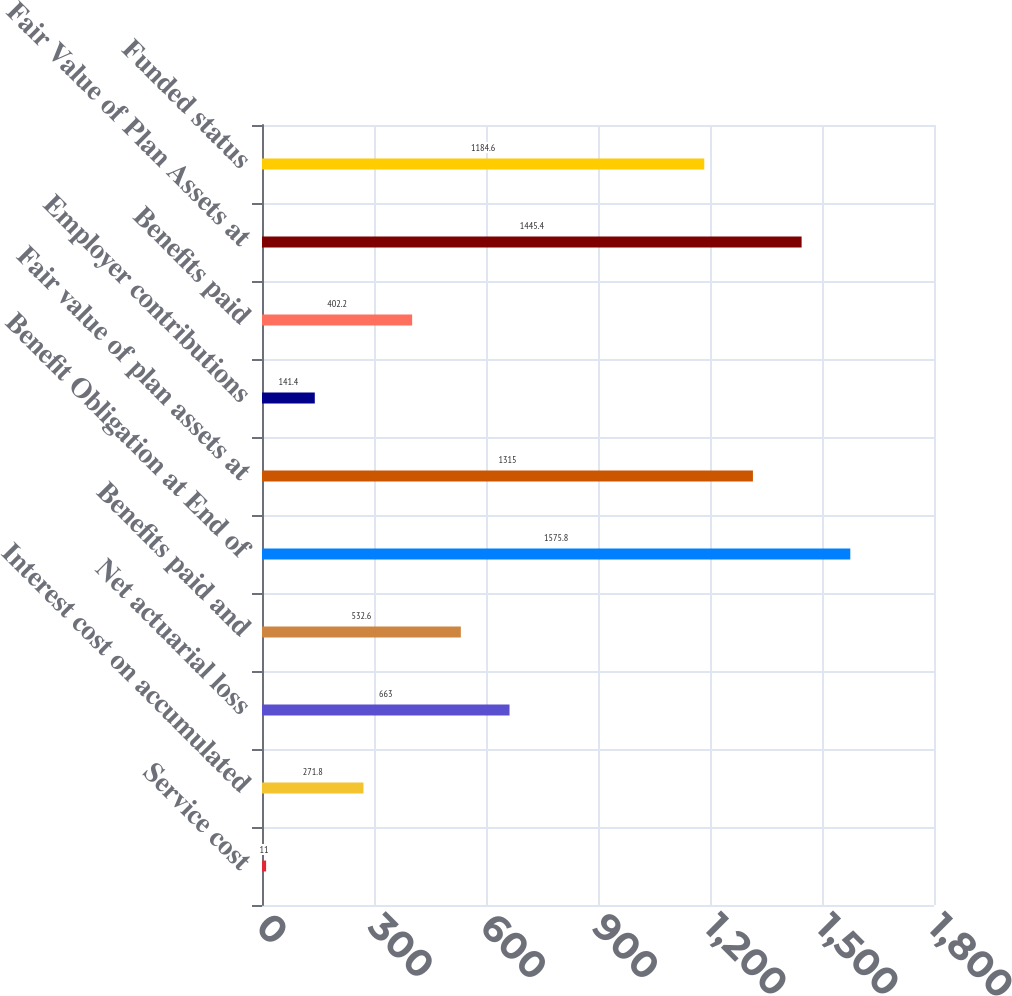Convert chart to OTSL. <chart><loc_0><loc_0><loc_500><loc_500><bar_chart><fcel>Service cost<fcel>Interest cost on accumulated<fcel>Net actuarial loss<fcel>Benefits paid and<fcel>Benefit Obligation at End of<fcel>Fair value of plan assets at<fcel>Employer contributions<fcel>Benefits paid<fcel>Fair Value of Plan Assets at<fcel>Funded status<nl><fcel>11<fcel>271.8<fcel>663<fcel>532.6<fcel>1575.8<fcel>1315<fcel>141.4<fcel>402.2<fcel>1445.4<fcel>1184.6<nl></chart> 